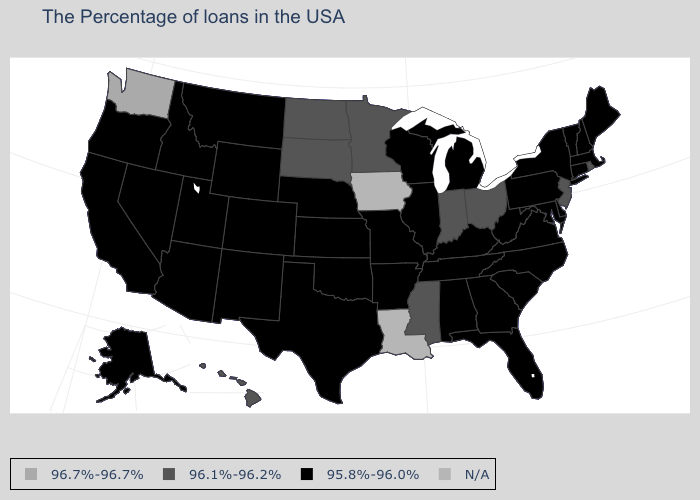Which states hav the highest value in the MidWest?
Quick response, please. Ohio, Indiana, Minnesota, South Dakota, North Dakota. Name the states that have a value in the range 95.8%-96.0%?
Write a very short answer. Maine, Massachusetts, New Hampshire, Vermont, Connecticut, New York, Delaware, Maryland, Pennsylvania, Virginia, North Carolina, South Carolina, West Virginia, Florida, Georgia, Michigan, Kentucky, Alabama, Tennessee, Wisconsin, Illinois, Missouri, Arkansas, Kansas, Nebraska, Oklahoma, Texas, Wyoming, Colorado, New Mexico, Utah, Montana, Arizona, Idaho, Nevada, California, Oregon, Alaska. What is the highest value in states that border Delaware?
Quick response, please. 96.1%-96.2%. What is the value of Hawaii?
Be succinct. 96.1%-96.2%. Among the states that border Indiana , does Ohio have the lowest value?
Write a very short answer. No. How many symbols are there in the legend?
Answer briefly. 4. What is the value of Colorado?
Short answer required. 95.8%-96.0%. What is the value of Utah?
Quick response, please. 95.8%-96.0%. Does New Mexico have the lowest value in the West?
Answer briefly. Yes. What is the value of Washington?
Quick response, please. 96.7%-96.7%. Name the states that have a value in the range 96.1%-96.2%?
Concise answer only. Rhode Island, New Jersey, Ohio, Indiana, Mississippi, Minnesota, South Dakota, North Dakota, Hawaii. Among the states that border Idaho , does Washington have the lowest value?
Short answer required. No. Name the states that have a value in the range 95.8%-96.0%?
Concise answer only. Maine, Massachusetts, New Hampshire, Vermont, Connecticut, New York, Delaware, Maryland, Pennsylvania, Virginia, North Carolina, South Carolina, West Virginia, Florida, Georgia, Michigan, Kentucky, Alabama, Tennessee, Wisconsin, Illinois, Missouri, Arkansas, Kansas, Nebraska, Oklahoma, Texas, Wyoming, Colorado, New Mexico, Utah, Montana, Arizona, Idaho, Nevada, California, Oregon, Alaska. Which states have the highest value in the USA?
Write a very short answer. Washington. 